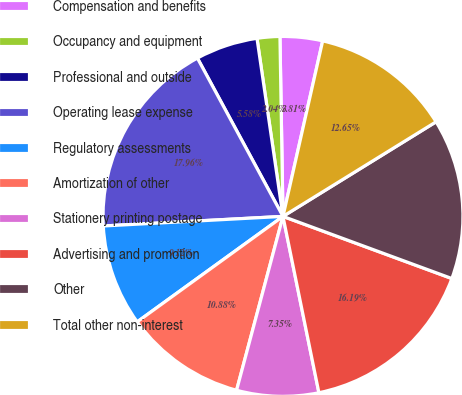Convert chart to OTSL. <chart><loc_0><loc_0><loc_500><loc_500><pie_chart><fcel>Compensation and benefits<fcel>Occupancy and equipment<fcel>Professional and outside<fcel>Operating lease expense<fcel>Regulatory assessments<fcel>Amortization of other<fcel>Stationery printing postage<fcel>Advertising and promotion<fcel>Other<fcel>Total other non-interest<nl><fcel>3.81%<fcel>2.04%<fcel>5.58%<fcel>17.96%<fcel>9.12%<fcel>10.88%<fcel>7.35%<fcel>16.19%<fcel>14.42%<fcel>12.65%<nl></chart> 